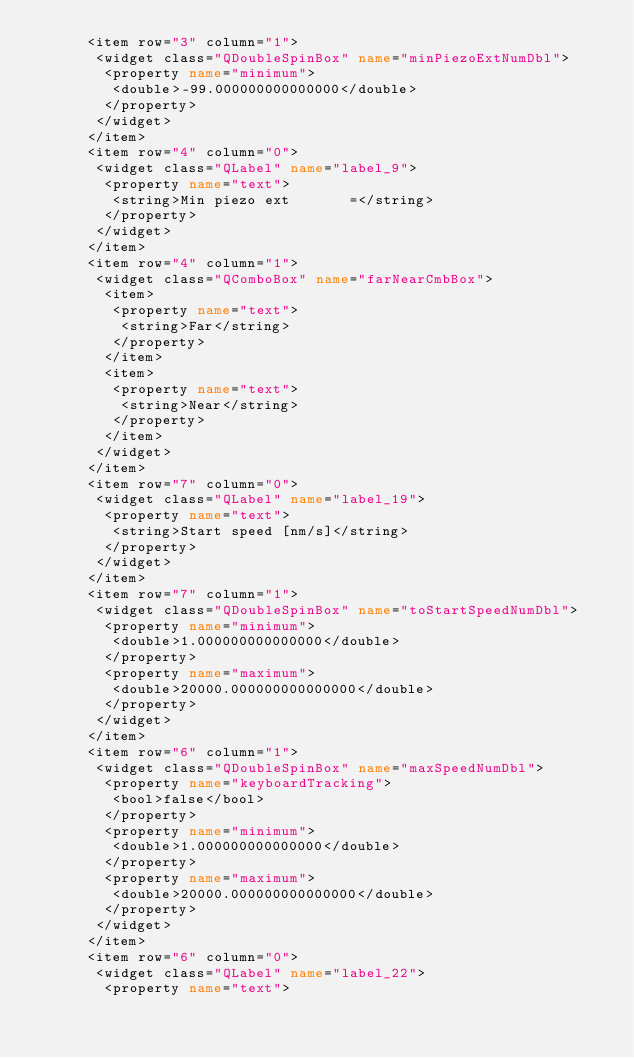<code> <loc_0><loc_0><loc_500><loc_500><_XML_>      <item row="3" column="1">
       <widget class="QDoubleSpinBox" name="minPiezoExtNumDbl">
        <property name="minimum">
         <double>-99.000000000000000</double>
        </property>
       </widget>
      </item>
      <item row="4" column="0">
       <widget class="QLabel" name="label_9">
        <property name="text">
         <string>Min piezo ext       =</string>
        </property>
       </widget>
      </item>
      <item row="4" column="1">
       <widget class="QComboBox" name="farNearCmbBox">
        <item>
         <property name="text">
          <string>Far</string>
         </property>
        </item>
        <item>
         <property name="text">
          <string>Near</string>
         </property>
        </item>
       </widget>
      </item>
      <item row="7" column="0">
       <widget class="QLabel" name="label_19">
        <property name="text">
         <string>Start speed [nm/s]</string>
        </property>
       </widget>
      </item>
      <item row="7" column="1">
       <widget class="QDoubleSpinBox" name="toStartSpeedNumDbl">
        <property name="minimum">
         <double>1.000000000000000</double>
        </property>
        <property name="maximum">
         <double>20000.000000000000000</double>
        </property>
       </widget>
      </item>
      <item row="6" column="1">
       <widget class="QDoubleSpinBox" name="maxSpeedNumDbl">
        <property name="keyboardTracking">
         <bool>false</bool>
        </property>
        <property name="minimum">
         <double>1.000000000000000</double>
        </property>
        <property name="maximum">
         <double>20000.000000000000000</double>
        </property>
       </widget>
      </item>
      <item row="6" column="0">
       <widget class="QLabel" name="label_22">
        <property name="text"></code> 